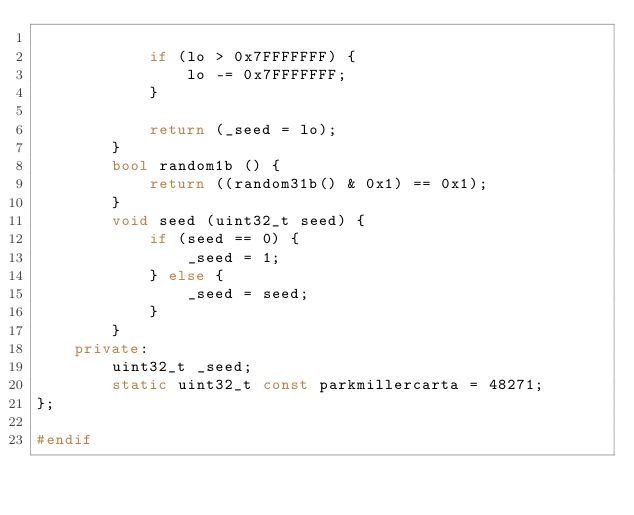<code> <loc_0><loc_0><loc_500><loc_500><_C++_>            
            if (lo > 0x7FFFFFFF) {
                lo -= 0x7FFFFFFF;
            }

            return (_seed = lo);
        }
        bool random1b () {
            return ((random31b() & 0x1) == 0x1);
        }
        void seed (uint32_t seed) {
            if (seed == 0) {
                _seed = 1;
            } else {
                _seed = seed;
            }
        }
    private:
        uint32_t _seed;
        static uint32_t const parkmillercarta = 48271;
};

#endif</code> 